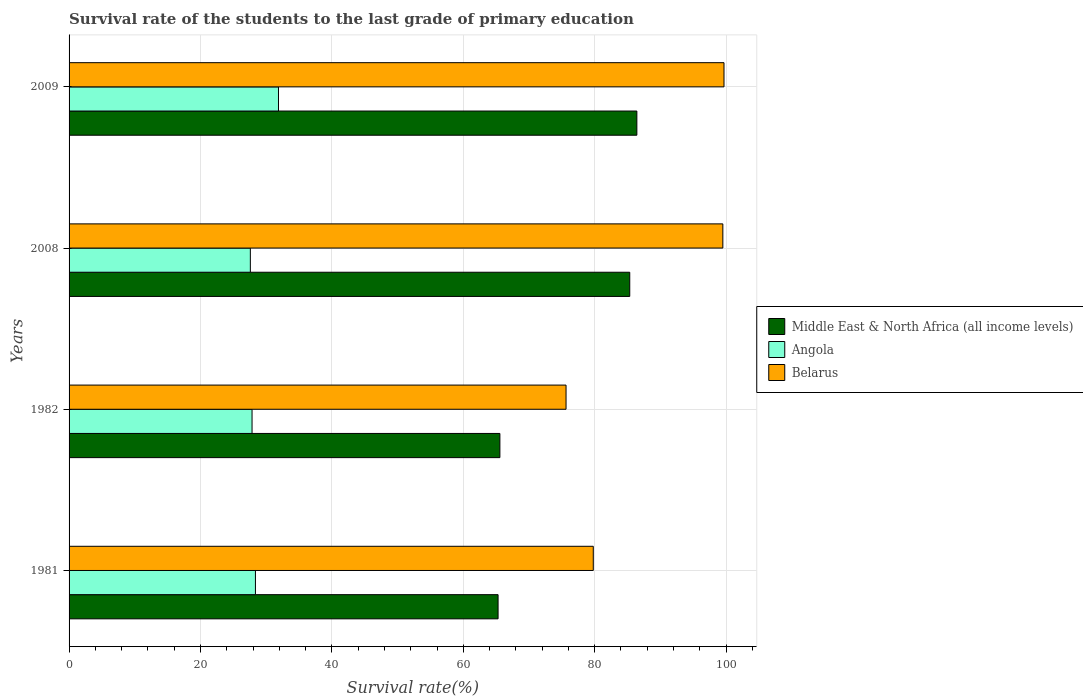Are the number of bars per tick equal to the number of legend labels?
Provide a short and direct response. Yes. What is the survival rate of the students in Middle East & North Africa (all income levels) in 1981?
Make the answer very short. 65.29. Across all years, what is the maximum survival rate of the students in Belarus?
Give a very brief answer. 99.68. Across all years, what is the minimum survival rate of the students in Belarus?
Your answer should be very brief. 75.64. In which year was the survival rate of the students in Middle East & North Africa (all income levels) minimum?
Your answer should be very brief. 1981. What is the total survival rate of the students in Middle East & North Africa (all income levels) in the graph?
Offer a very short reply. 302.62. What is the difference between the survival rate of the students in Belarus in 1982 and that in 2009?
Provide a short and direct response. -24.04. What is the difference between the survival rate of the students in Angola in 1981 and the survival rate of the students in Belarus in 2009?
Offer a terse response. -71.31. What is the average survival rate of the students in Angola per year?
Keep it short and to the point. 28.92. In the year 1982, what is the difference between the survival rate of the students in Belarus and survival rate of the students in Angola?
Ensure brevity in your answer.  47.79. What is the ratio of the survival rate of the students in Middle East & North Africa (all income levels) in 1982 to that in 2008?
Give a very brief answer. 0.77. What is the difference between the highest and the second highest survival rate of the students in Middle East & North Africa (all income levels)?
Give a very brief answer. 1.08. What is the difference between the highest and the lowest survival rate of the students in Middle East & North Africa (all income levels)?
Keep it short and to the point. 21.12. What does the 2nd bar from the top in 1982 represents?
Offer a very short reply. Angola. What does the 3rd bar from the bottom in 1982 represents?
Provide a succinct answer. Belarus. Is it the case that in every year, the sum of the survival rate of the students in Angola and survival rate of the students in Middle East & North Africa (all income levels) is greater than the survival rate of the students in Belarus?
Provide a succinct answer. Yes. What is the difference between two consecutive major ticks on the X-axis?
Provide a short and direct response. 20. Does the graph contain any zero values?
Offer a very short reply. No. Does the graph contain grids?
Your response must be concise. Yes. Where does the legend appear in the graph?
Offer a very short reply. Center right. How many legend labels are there?
Your answer should be compact. 3. What is the title of the graph?
Give a very brief answer. Survival rate of the students to the last grade of primary education. What is the label or title of the X-axis?
Keep it short and to the point. Survival rate(%). What is the label or title of the Y-axis?
Your response must be concise. Years. What is the Survival rate(%) in Middle East & North Africa (all income levels) in 1981?
Give a very brief answer. 65.29. What is the Survival rate(%) of Angola in 1981?
Your response must be concise. 28.37. What is the Survival rate(%) of Belarus in 1981?
Give a very brief answer. 79.78. What is the Survival rate(%) in Middle East & North Africa (all income levels) in 1982?
Offer a very short reply. 65.57. What is the Survival rate(%) in Angola in 1982?
Offer a terse response. 27.85. What is the Survival rate(%) of Belarus in 1982?
Make the answer very short. 75.64. What is the Survival rate(%) of Middle East & North Africa (all income levels) in 2008?
Provide a succinct answer. 85.34. What is the Survival rate(%) in Angola in 2008?
Provide a short and direct response. 27.59. What is the Survival rate(%) of Belarus in 2008?
Your answer should be compact. 99.5. What is the Survival rate(%) of Middle East & North Africa (all income levels) in 2009?
Provide a succinct answer. 86.42. What is the Survival rate(%) in Angola in 2009?
Offer a terse response. 31.87. What is the Survival rate(%) of Belarus in 2009?
Keep it short and to the point. 99.68. Across all years, what is the maximum Survival rate(%) of Middle East & North Africa (all income levels)?
Offer a very short reply. 86.42. Across all years, what is the maximum Survival rate(%) in Angola?
Keep it short and to the point. 31.87. Across all years, what is the maximum Survival rate(%) of Belarus?
Make the answer very short. 99.68. Across all years, what is the minimum Survival rate(%) in Middle East & North Africa (all income levels)?
Ensure brevity in your answer.  65.29. Across all years, what is the minimum Survival rate(%) in Angola?
Your answer should be compact. 27.59. Across all years, what is the minimum Survival rate(%) in Belarus?
Keep it short and to the point. 75.64. What is the total Survival rate(%) in Middle East & North Africa (all income levels) in the graph?
Keep it short and to the point. 302.62. What is the total Survival rate(%) of Angola in the graph?
Keep it short and to the point. 115.68. What is the total Survival rate(%) of Belarus in the graph?
Give a very brief answer. 354.6. What is the difference between the Survival rate(%) in Middle East & North Africa (all income levels) in 1981 and that in 1982?
Your answer should be compact. -0.28. What is the difference between the Survival rate(%) of Angola in 1981 and that in 1982?
Offer a very short reply. 0.52. What is the difference between the Survival rate(%) of Belarus in 1981 and that in 1982?
Your answer should be compact. 4.15. What is the difference between the Survival rate(%) of Middle East & North Africa (all income levels) in 1981 and that in 2008?
Give a very brief answer. -20.04. What is the difference between the Survival rate(%) in Angola in 1981 and that in 2008?
Give a very brief answer. 0.77. What is the difference between the Survival rate(%) in Belarus in 1981 and that in 2008?
Offer a very short reply. -19.72. What is the difference between the Survival rate(%) of Middle East & North Africa (all income levels) in 1981 and that in 2009?
Offer a terse response. -21.12. What is the difference between the Survival rate(%) of Angola in 1981 and that in 2009?
Ensure brevity in your answer.  -3.51. What is the difference between the Survival rate(%) in Belarus in 1981 and that in 2009?
Give a very brief answer. -19.9. What is the difference between the Survival rate(%) of Middle East & North Africa (all income levels) in 1982 and that in 2008?
Offer a very short reply. -19.77. What is the difference between the Survival rate(%) in Angola in 1982 and that in 2008?
Offer a very short reply. 0.26. What is the difference between the Survival rate(%) in Belarus in 1982 and that in 2008?
Your answer should be compact. -23.87. What is the difference between the Survival rate(%) in Middle East & North Africa (all income levels) in 1982 and that in 2009?
Your answer should be compact. -20.85. What is the difference between the Survival rate(%) in Angola in 1982 and that in 2009?
Provide a short and direct response. -4.02. What is the difference between the Survival rate(%) of Belarus in 1982 and that in 2009?
Provide a succinct answer. -24.04. What is the difference between the Survival rate(%) in Middle East & North Africa (all income levels) in 2008 and that in 2009?
Offer a terse response. -1.08. What is the difference between the Survival rate(%) of Angola in 2008 and that in 2009?
Ensure brevity in your answer.  -4.28. What is the difference between the Survival rate(%) in Belarus in 2008 and that in 2009?
Provide a short and direct response. -0.18. What is the difference between the Survival rate(%) of Middle East & North Africa (all income levels) in 1981 and the Survival rate(%) of Angola in 1982?
Offer a terse response. 37.45. What is the difference between the Survival rate(%) in Middle East & North Africa (all income levels) in 1981 and the Survival rate(%) in Belarus in 1982?
Offer a very short reply. -10.34. What is the difference between the Survival rate(%) of Angola in 1981 and the Survival rate(%) of Belarus in 1982?
Ensure brevity in your answer.  -47.27. What is the difference between the Survival rate(%) of Middle East & North Africa (all income levels) in 1981 and the Survival rate(%) of Angola in 2008?
Your answer should be very brief. 37.7. What is the difference between the Survival rate(%) in Middle East & North Africa (all income levels) in 1981 and the Survival rate(%) in Belarus in 2008?
Make the answer very short. -34.21. What is the difference between the Survival rate(%) in Angola in 1981 and the Survival rate(%) in Belarus in 2008?
Your answer should be compact. -71.14. What is the difference between the Survival rate(%) of Middle East & North Africa (all income levels) in 1981 and the Survival rate(%) of Angola in 2009?
Keep it short and to the point. 33.42. What is the difference between the Survival rate(%) of Middle East & North Africa (all income levels) in 1981 and the Survival rate(%) of Belarus in 2009?
Give a very brief answer. -34.38. What is the difference between the Survival rate(%) of Angola in 1981 and the Survival rate(%) of Belarus in 2009?
Ensure brevity in your answer.  -71.31. What is the difference between the Survival rate(%) in Middle East & North Africa (all income levels) in 1982 and the Survival rate(%) in Angola in 2008?
Offer a very short reply. 37.98. What is the difference between the Survival rate(%) of Middle East & North Africa (all income levels) in 1982 and the Survival rate(%) of Belarus in 2008?
Ensure brevity in your answer.  -33.93. What is the difference between the Survival rate(%) in Angola in 1982 and the Survival rate(%) in Belarus in 2008?
Your response must be concise. -71.65. What is the difference between the Survival rate(%) of Middle East & North Africa (all income levels) in 1982 and the Survival rate(%) of Angola in 2009?
Provide a short and direct response. 33.7. What is the difference between the Survival rate(%) of Middle East & North Africa (all income levels) in 1982 and the Survival rate(%) of Belarus in 2009?
Make the answer very short. -34.11. What is the difference between the Survival rate(%) of Angola in 1982 and the Survival rate(%) of Belarus in 2009?
Provide a succinct answer. -71.83. What is the difference between the Survival rate(%) in Middle East & North Africa (all income levels) in 2008 and the Survival rate(%) in Angola in 2009?
Provide a succinct answer. 53.46. What is the difference between the Survival rate(%) in Middle East & North Africa (all income levels) in 2008 and the Survival rate(%) in Belarus in 2009?
Your response must be concise. -14.34. What is the difference between the Survival rate(%) of Angola in 2008 and the Survival rate(%) of Belarus in 2009?
Provide a succinct answer. -72.09. What is the average Survival rate(%) in Middle East & North Africa (all income levels) per year?
Your answer should be very brief. 75.65. What is the average Survival rate(%) of Angola per year?
Ensure brevity in your answer.  28.92. What is the average Survival rate(%) in Belarus per year?
Make the answer very short. 88.65. In the year 1981, what is the difference between the Survival rate(%) in Middle East & North Africa (all income levels) and Survival rate(%) in Angola?
Ensure brevity in your answer.  36.93. In the year 1981, what is the difference between the Survival rate(%) in Middle East & North Africa (all income levels) and Survival rate(%) in Belarus?
Offer a terse response. -14.49. In the year 1981, what is the difference between the Survival rate(%) of Angola and Survival rate(%) of Belarus?
Give a very brief answer. -51.42. In the year 1982, what is the difference between the Survival rate(%) in Middle East & North Africa (all income levels) and Survival rate(%) in Angola?
Give a very brief answer. 37.72. In the year 1982, what is the difference between the Survival rate(%) of Middle East & North Africa (all income levels) and Survival rate(%) of Belarus?
Your answer should be compact. -10.07. In the year 1982, what is the difference between the Survival rate(%) of Angola and Survival rate(%) of Belarus?
Give a very brief answer. -47.79. In the year 2008, what is the difference between the Survival rate(%) in Middle East & North Africa (all income levels) and Survival rate(%) in Angola?
Ensure brevity in your answer.  57.74. In the year 2008, what is the difference between the Survival rate(%) of Middle East & North Africa (all income levels) and Survival rate(%) of Belarus?
Provide a succinct answer. -14.17. In the year 2008, what is the difference between the Survival rate(%) in Angola and Survival rate(%) in Belarus?
Ensure brevity in your answer.  -71.91. In the year 2009, what is the difference between the Survival rate(%) in Middle East & North Africa (all income levels) and Survival rate(%) in Angola?
Offer a very short reply. 54.54. In the year 2009, what is the difference between the Survival rate(%) in Middle East & North Africa (all income levels) and Survival rate(%) in Belarus?
Your response must be concise. -13.26. In the year 2009, what is the difference between the Survival rate(%) in Angola and Survival rate(%) in Belarus?
Give a very brief answer. -67.81. What is the ratio of the Survival rate(%) in Middle East & North Africa (all income levels) in 1981 to that in 1982?
Keep it short and to the point. 1. What is the ratio of the Survival rate(%) in Angola in 1981 to that in 1982?
Offer a very short reply. 1.02. What is the ratio of the Survival rate(%) in Belarus in 1981 to that in 1982?
Offer a terse response. 1.05. What is the ratio of the Survival rate(%) of Middle East & North Africa (all income levels) in 1981 to that in 2008?
Offer a terse response. 0.77. What is the ratio of the Survival rate(%) in Angola in 1981 to that in 2008?
Offer a very short reply. 1.03. What is the ratio of the Survival rate(%) of Belarus in 1981 to that in 2008?
Give a very brief answer. 0.8. What is the ratio of the Survival rate(%) of Middle East & North Africa (all income levels) in 1981 to that in 2009?
Offer a very short reply. 0.76. What is the ratio of the Survival rate(%) in Angola in 1981 to that in 2009?
Make the answer very short. 0.89. What is the ratio of the Survival rate(%) in Belarus in 1981 to that in 2009?
Provide a short and direct response. 0.8. What is the ratio of the Survival rate(%) of Middle East & North Africa (all income levels) in 1982 to that in 2008?
Ensure brevity in your answer.  0.77. What is the ratio of the Survival rate(%) in Angola in 1982 to that in 2008?
Your answer should be very brief. 1.01. What is the ratio of the Survival rate(%) of Belarus in 1982 to that in 2008?
Offer a terse response. 0.76. What is the ratio of the Survival rate(%) of Middle East & North Africa (all income levels) in 1982 to that in 2009?
Provide a succinct answer. 0.76. What is the ratio of the Survival rate(%) in Angola in 1982 to that in 2009?
Offer a terse response. 0.87. What is the ratio of the Survival rate(%) of Belarus in 1982 to that in 2009?
Give a very brief answer. 0.76. What is the ratio of the Survival rate(%) in Middle East & North Africa (all income levels) in 2008 to that in 2009?
Give a very brief answer. 0.99. What is the ratio of the Survival rate(%) in Angola in 2008 to that in 2009?
Your response must be concise. 0.87. What is the ratio of the Survival rate(%) of Belarus in 2008 to that in 2009?
Give a very brief answer. 1. What is the difference between the highest and the second highest Survival rate(%) in Middle East & North Africa (all income levels)?
Give a very brief answer. 1.08. What is the difference between the highest and the second highest Survival rate(%) in Angola?
Your answer should be compact. 3.51. What is the difference between the highest and the second highest Survival rate(%) in Belarus?
Offer a very short reply. 0.18. What is the difference between the highest and the lowest Survival rate(%) of Middle East & North Africa (all income levels)?
Provide a succinct answer. 21.12. What is the difference between the highest and the lowest Survival rate(%) in Angola?
Provide a succinct answer. 4.28. What is the difference between the highest and the lowest Survival rate(%) of Belarus?
Offer a terse response. 24.04. 